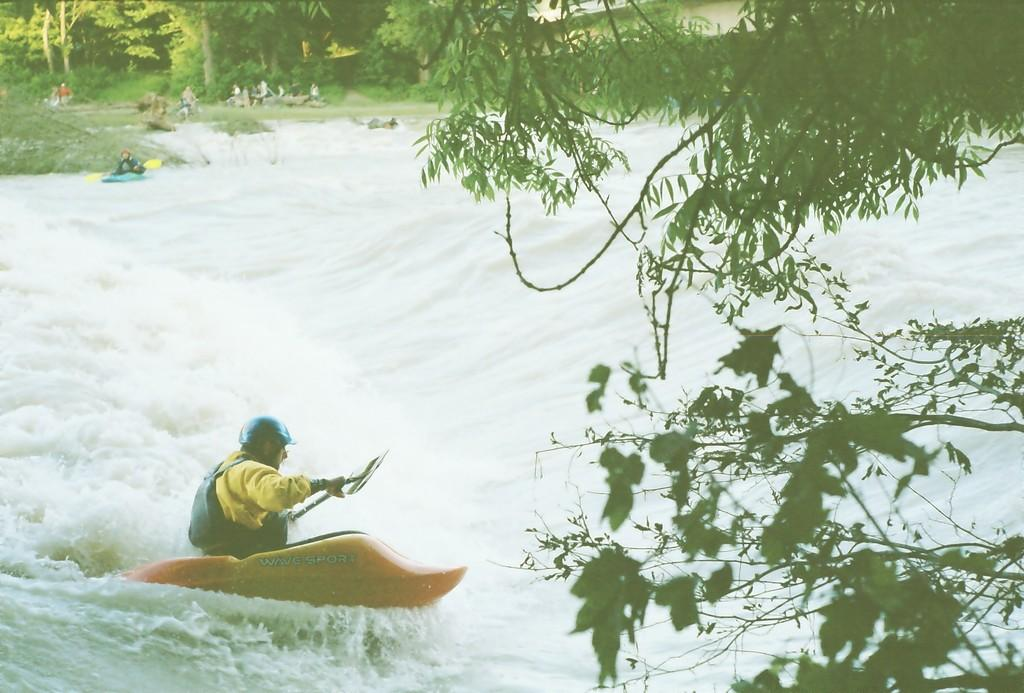What are the persons in the image doing? The persons in the image are on a kayak. What are they using to propel the kayak? They are holding paddles. Where are they located in the image? They are on water. What type of vegetation can be seen in the image? There are trees visible in the image, and branches on the right side. What direction is the carpenter facing in the image? There is no carpenter present in the image; it features persons on a kayak. What type of yam is being used as a paddle in the image? There is no yam being used as a paddle in the image; they are using actual paddles. 